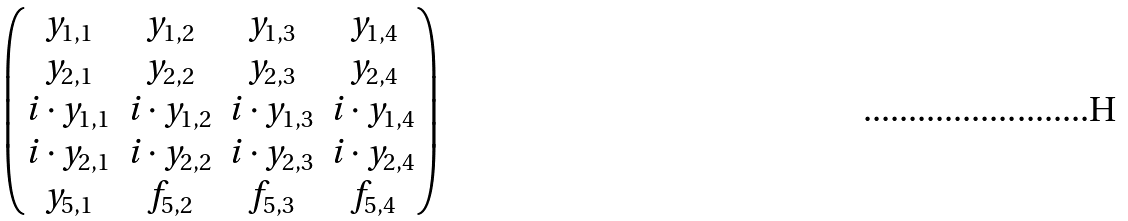<formula> <loc_0><loc_0><loc_500><loc_500>\begin{pmatrix} y _ { 1 , 1 } & y _ { 1 , 2 } & y _ { 1 , 3 } & y _ { 1 , 4 } \\ y _ { 2 , 1 } & y _ { 2 , 2 } & y _ { 2 , 3 } & y _ { 2 , 4 } \\ i \cdot y _ { 1 , 1 } & i \cdot y _ { 1 , 2 } & i \cdot y _ { 1 , 3 } & i \cdot y _ { 1 , 4 } \\ i \cdot y _ { 2 , 1 } & i \cdot y _ { 2 , 2 } & i \cdot y _ { 2 , 3 } & i \cdot y _ { 2 , 4 } \\ y _ { 5 , 1 } & f _ { 5 , 2 } & f _ { 5 , 3 } & f _ { 5 , 4 } \end{pmatrix}</formula> 